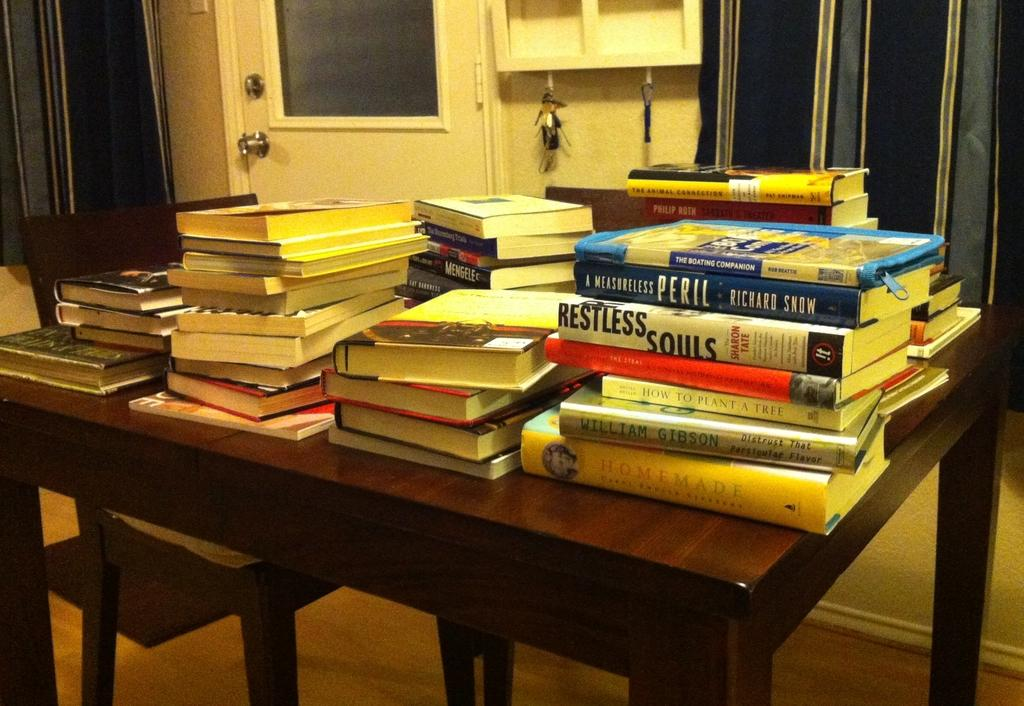What type of furniture is present in the image? There is a table and a chair in the image. What items can be seen on the table? There are books on the table in the image. What architectural feature is visible in the image? There is a door in the image. What type of window treatment is present in the image? There is a curtain in the image. What small objects are visible in the image? There are keys in the image. What type of teaching is happening in the image? There is no teaching activity depicted in the image. How does the curtain lift itself in the image? The curtain does not lift itself in the image; it is stationary. 